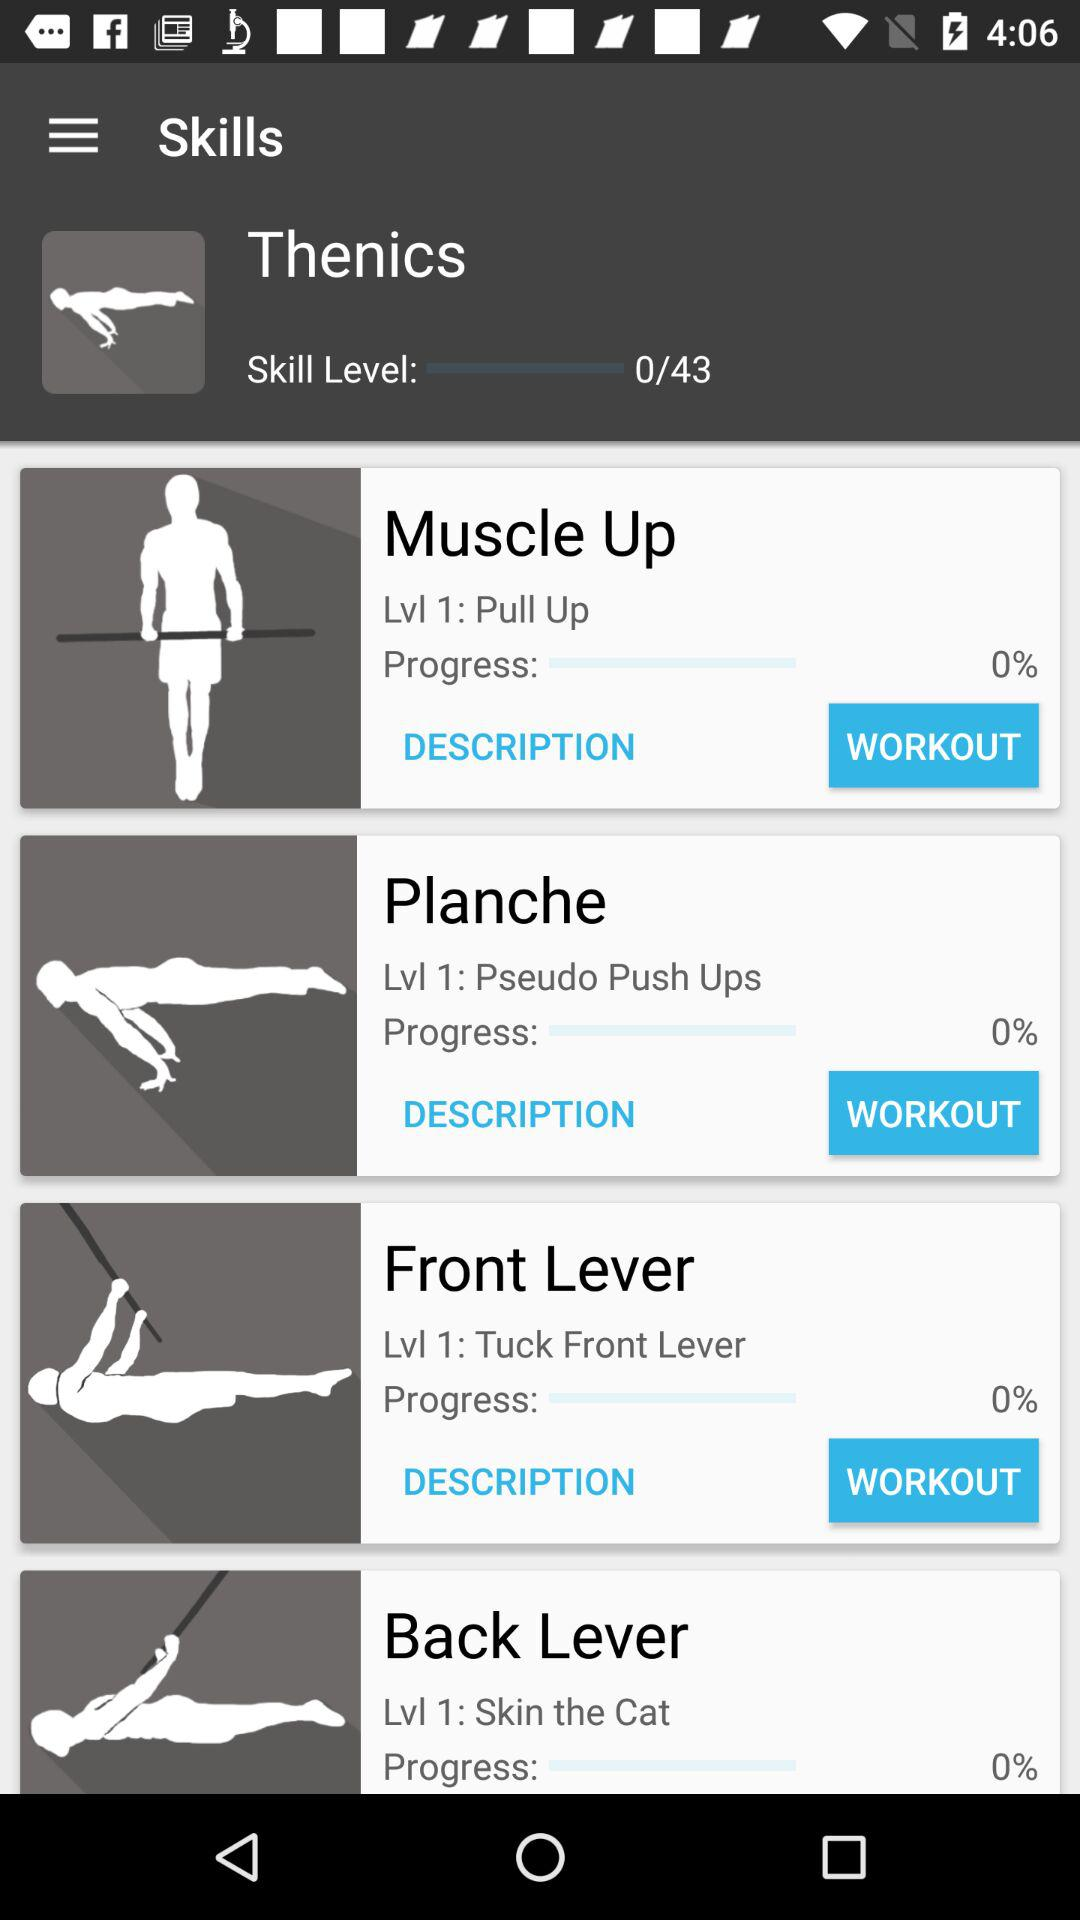How many skill levels in total are there in "Thenics"? There are a total of 43 skill levels in "Thenics". 